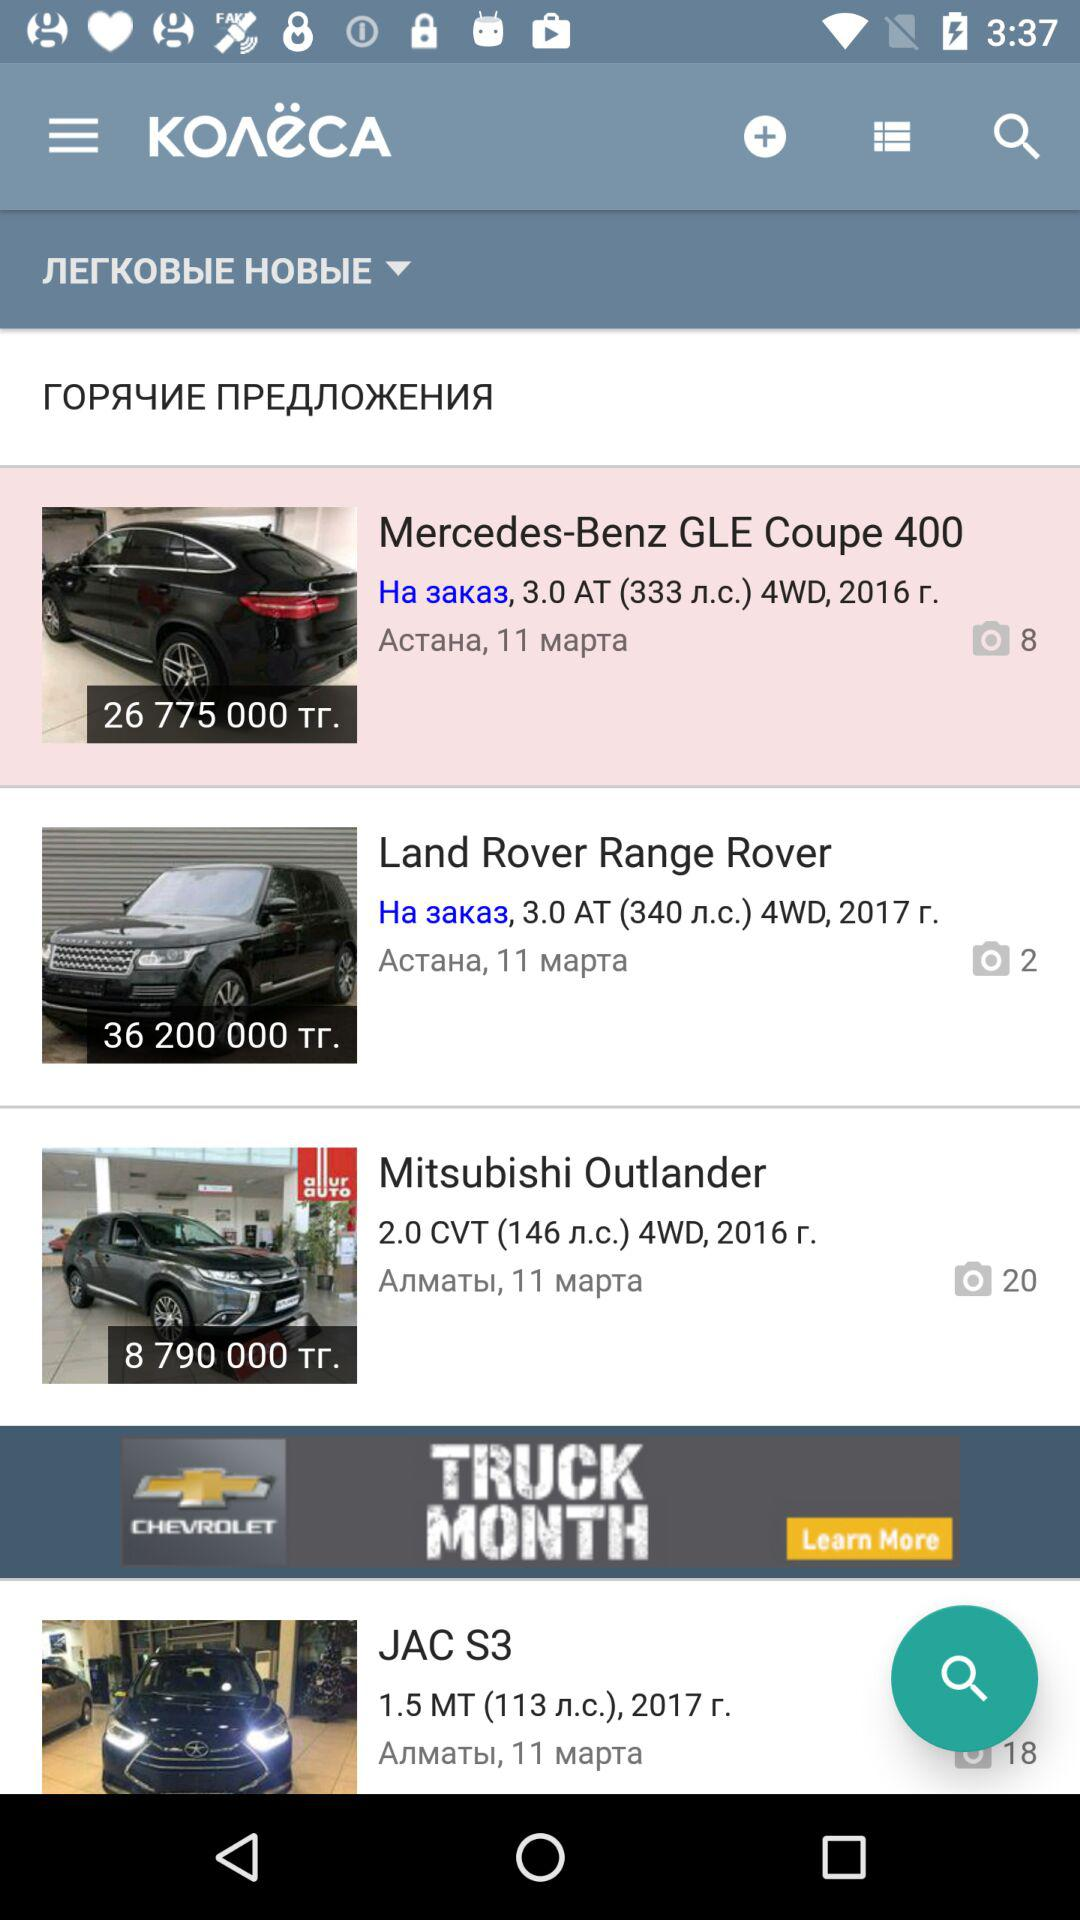How many images are there in the Land Rover Range Rover? There are 2 images. 